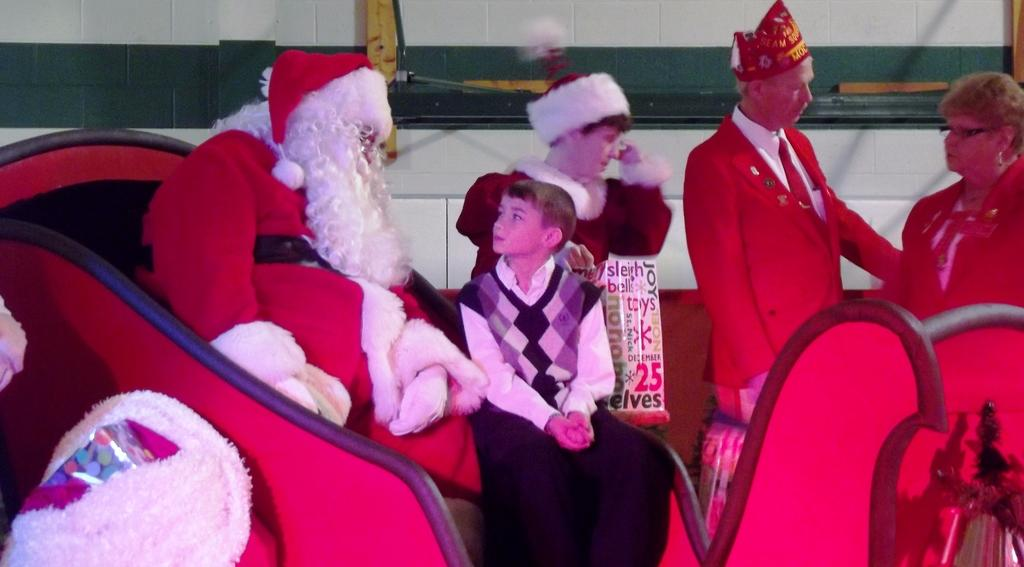How many people are in the image? There are people in the image. Can you describe the appearance of one of the people? One person is wearing a Santa Claus costume. What is the boy doing in the image? A boy is sitting beside the person in the Santa Claus costume. What can be seen on the wall in the background of the image? There is a poster in the image. What is the background of the image composed of? There is a wall in the background of the image. What type of fifth is being celebrated in the image? There is no indication of a specific event or celebration in the image, and the term "fifth" is not mentioned in the provided facts. 